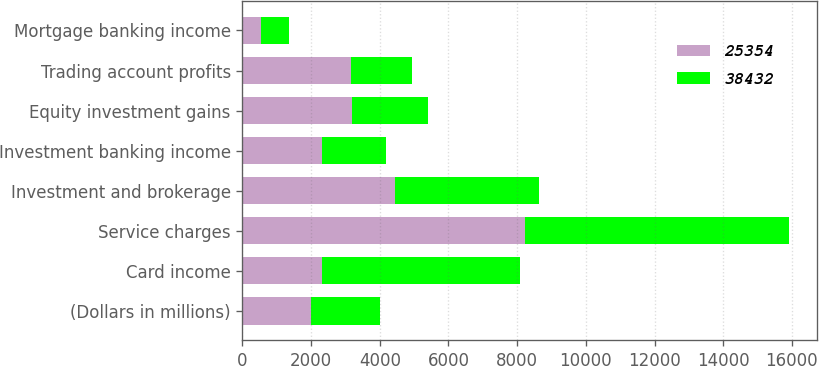Convert chart to OTSL. <chart><loc_0><loc_0><loc_500><loc_500><stacked_bar_chart><ecel><fcel>(Dollars in millions)<fcel>Card income<fcel>Service charges<fcel>Investment and brokerage<fcel>Investment banking income<fcel>Equity investment gains<fcel>Trading account profits<fcel>Mortgage banking income<nl><fcel>25354<fcel>2006<fcel>2317<fcel>8224<fcel>4456<fcel>2317<fcel>3189<fcel>3166<fcel>541<nl><fcel>38432<fcel>2005<fcel>5753<fcel>7704<fcel>4184<fcel>1856<fcel>2212<fcel>1763<fcel>805<nl></chart> 